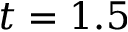<formula> <loc_0><loc_0><loc_500><loc_500>t = 1 . 5</formula> 